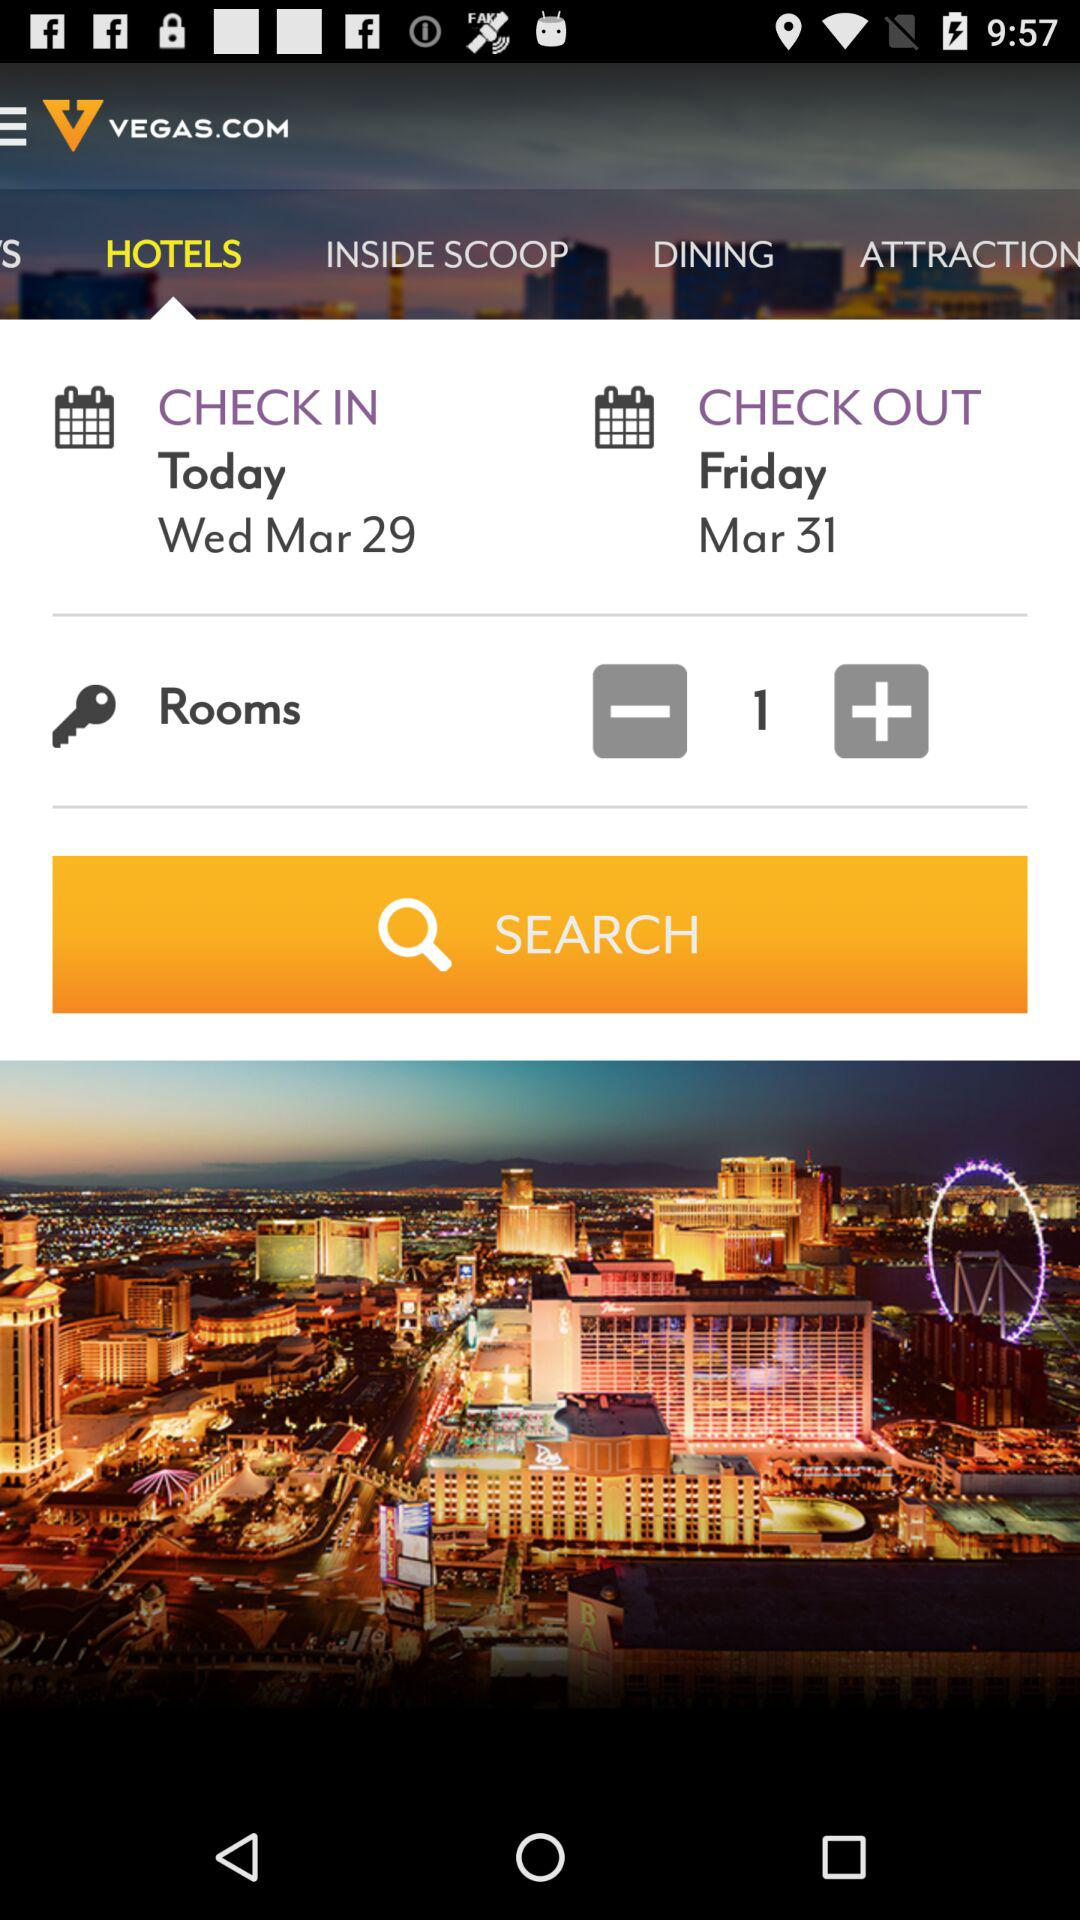Which tab is selected? The selected tab is "HOTELS". 